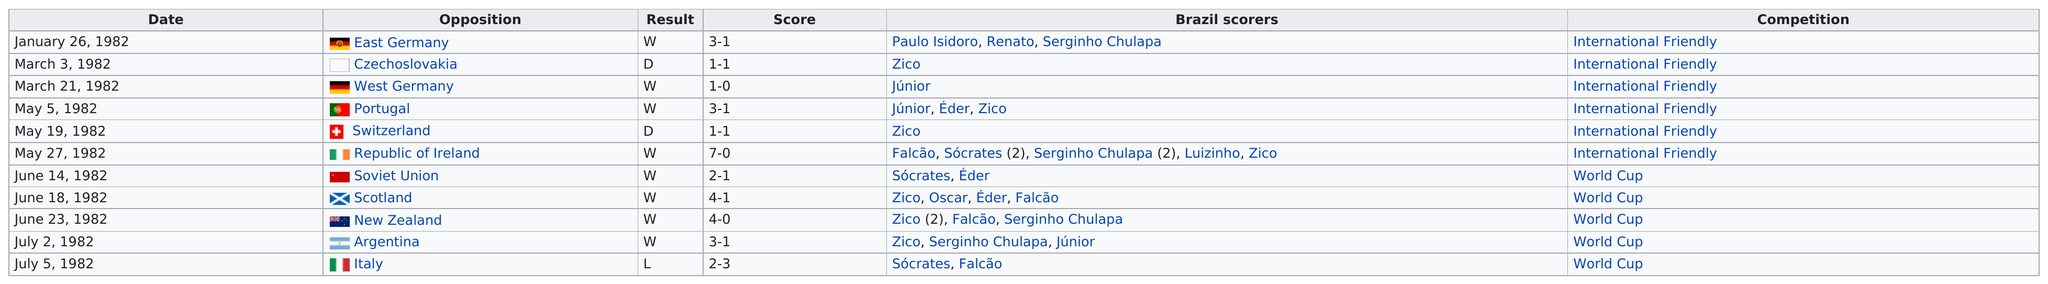Specify some key components in this picture. Brazil has won a total of 8 world cup matches. The team played 11 games in 1982. The team's next opponent after facing the Soviet Union on June 14 was Scotland, who they faced on June 18. Brazil played West Germany a total of 1 time during the 1982 soccer season. The total number of losses that Brazil suffered was 1. 